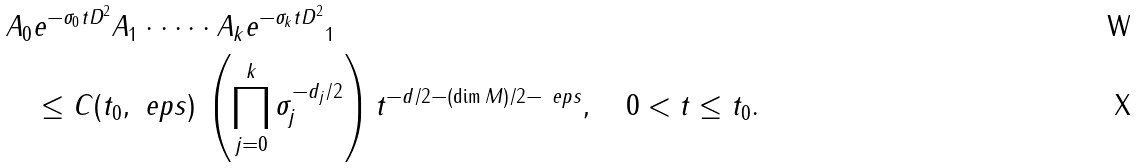Convert formula to latex. <formula><loc_0><loc_0><loc_500><loc_500>\| A _ { 0 } & e ^ { - \sigma _ { 0 } t D ^ { 2 } } A _ { 1 } \cdot \dots \cdot A _ { k } e ^ { - \sigma _ { k } t D ^ { 2 } } \| _ { 1 } \\ & \leq C ( t _ { 0 } , \ e p s ) \, \left ( \prod _ { j = 0 } ^ { k } \sigma _ { j } ^ { - d _ { j } / 2 } \right ) t ^ { - d / 2 - ( \dim M ) / 2 - \ e p s } , \quad 0 < t \leq t _ { 0 } .</formula> 